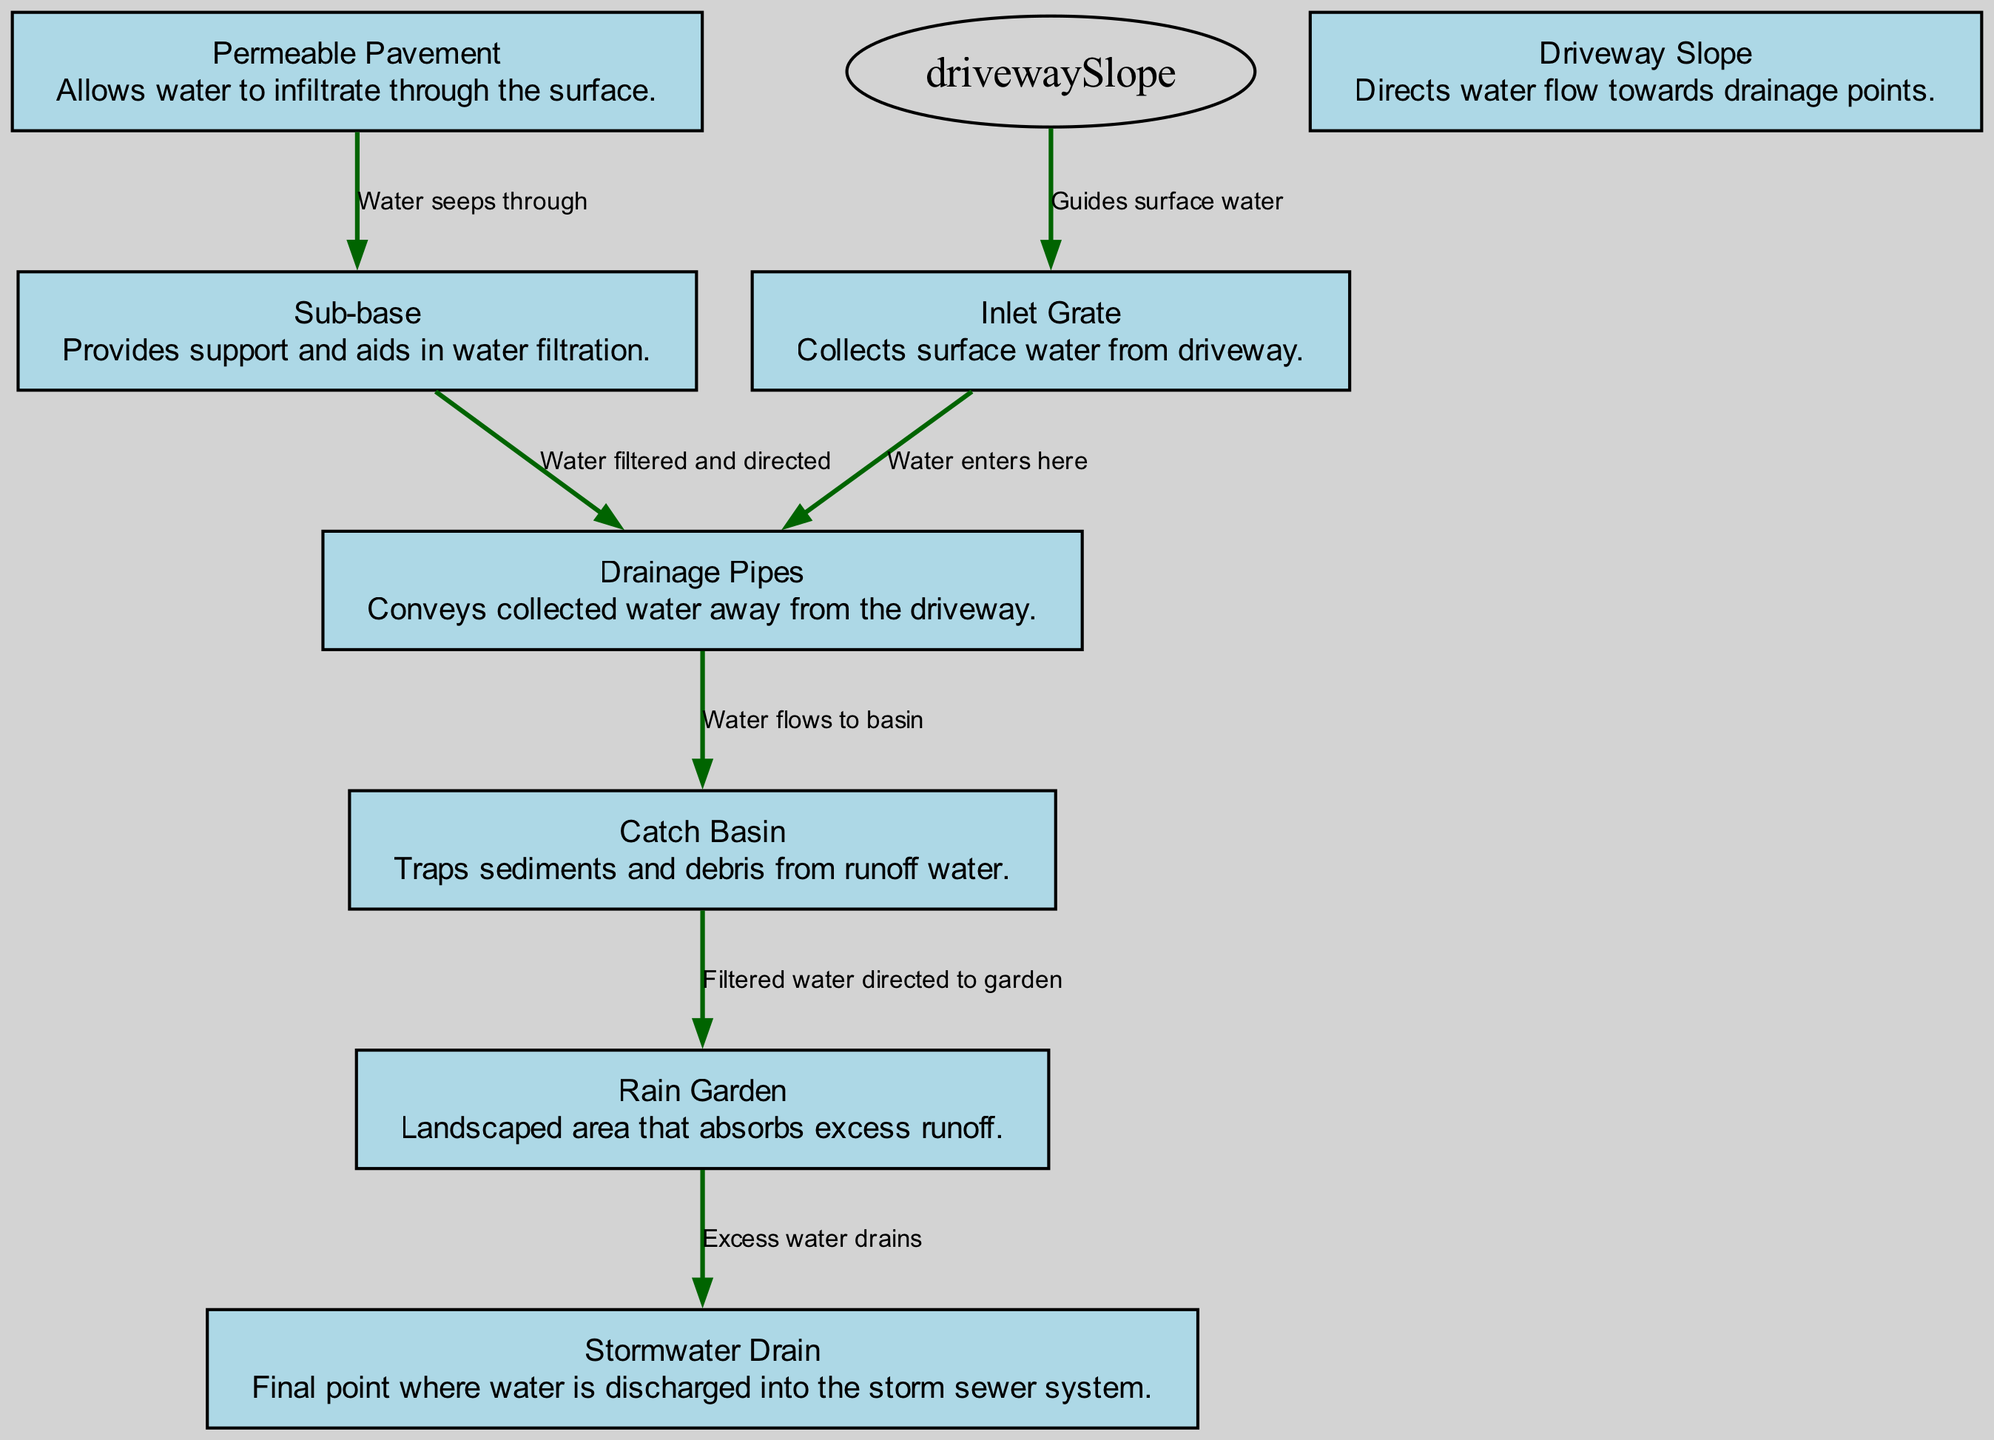What is the first point where water is collected in the drainage system? The diagram shows that the first point of water collection is indicated by the "Inlet Grate." This is where surface water from the driveway enters the drainage system.
Answer: Inlet Grate How many nodes are present in the diagram? By counting the nodes listed, there are eight distinct components of the drainage system illustrated, which include "Inlet Grate," "Permeable Pavement," "Drainage Pipes," "Catch Basin," "Sub-base," "Driveway Slope," "Rain Garden," and "Stormwater Drain."
Answer: Eight What collects sediments and debris from runoff water? The "Catch Basin" is specifically indicated in the diagram as the component that traps sediments and debris from the water runoff, ensuring cleaner water is directed downstream.
Answer: Catch Basin Which component allows water to infiltrate through its surface? The "Permeable Pavement" is identified in the diagram as the component that permits water to seep through its surface, enhancing water infiltration and reducing runoff.
Answer: Permeable Pavement What is the final discharge point for water in this system? According to the diagram, water is ultimately discharged into the storm sewer system through the "Stormwater Drain," which serves as the last point in the water management process.
Answer: Stormwater Drain How does surface water flow towards the drainage system? The "Driveway Slope" directs surface water towards the drainage points, specifically guiding it to the "Inlet Grate," which is the starting point of the drainage system, ensuring efficient water management.
Answer: Driveway Slope What is the role of the sub-base in the drainage system? The "Sub-base" serves a dual purpose: it provides structural support for the driveway while also aiding in the filtration of water, directing it towards the drainage pipes for further management.
Answer: Support and filtration Where does the filtered water from the catch basin go? Based on the diagram, the path of filtered water from the "Catch Basin" leads to the "Rain Garden," which absorbs the water, reducing runoff and improving water management.
Answer: Rain Garden 